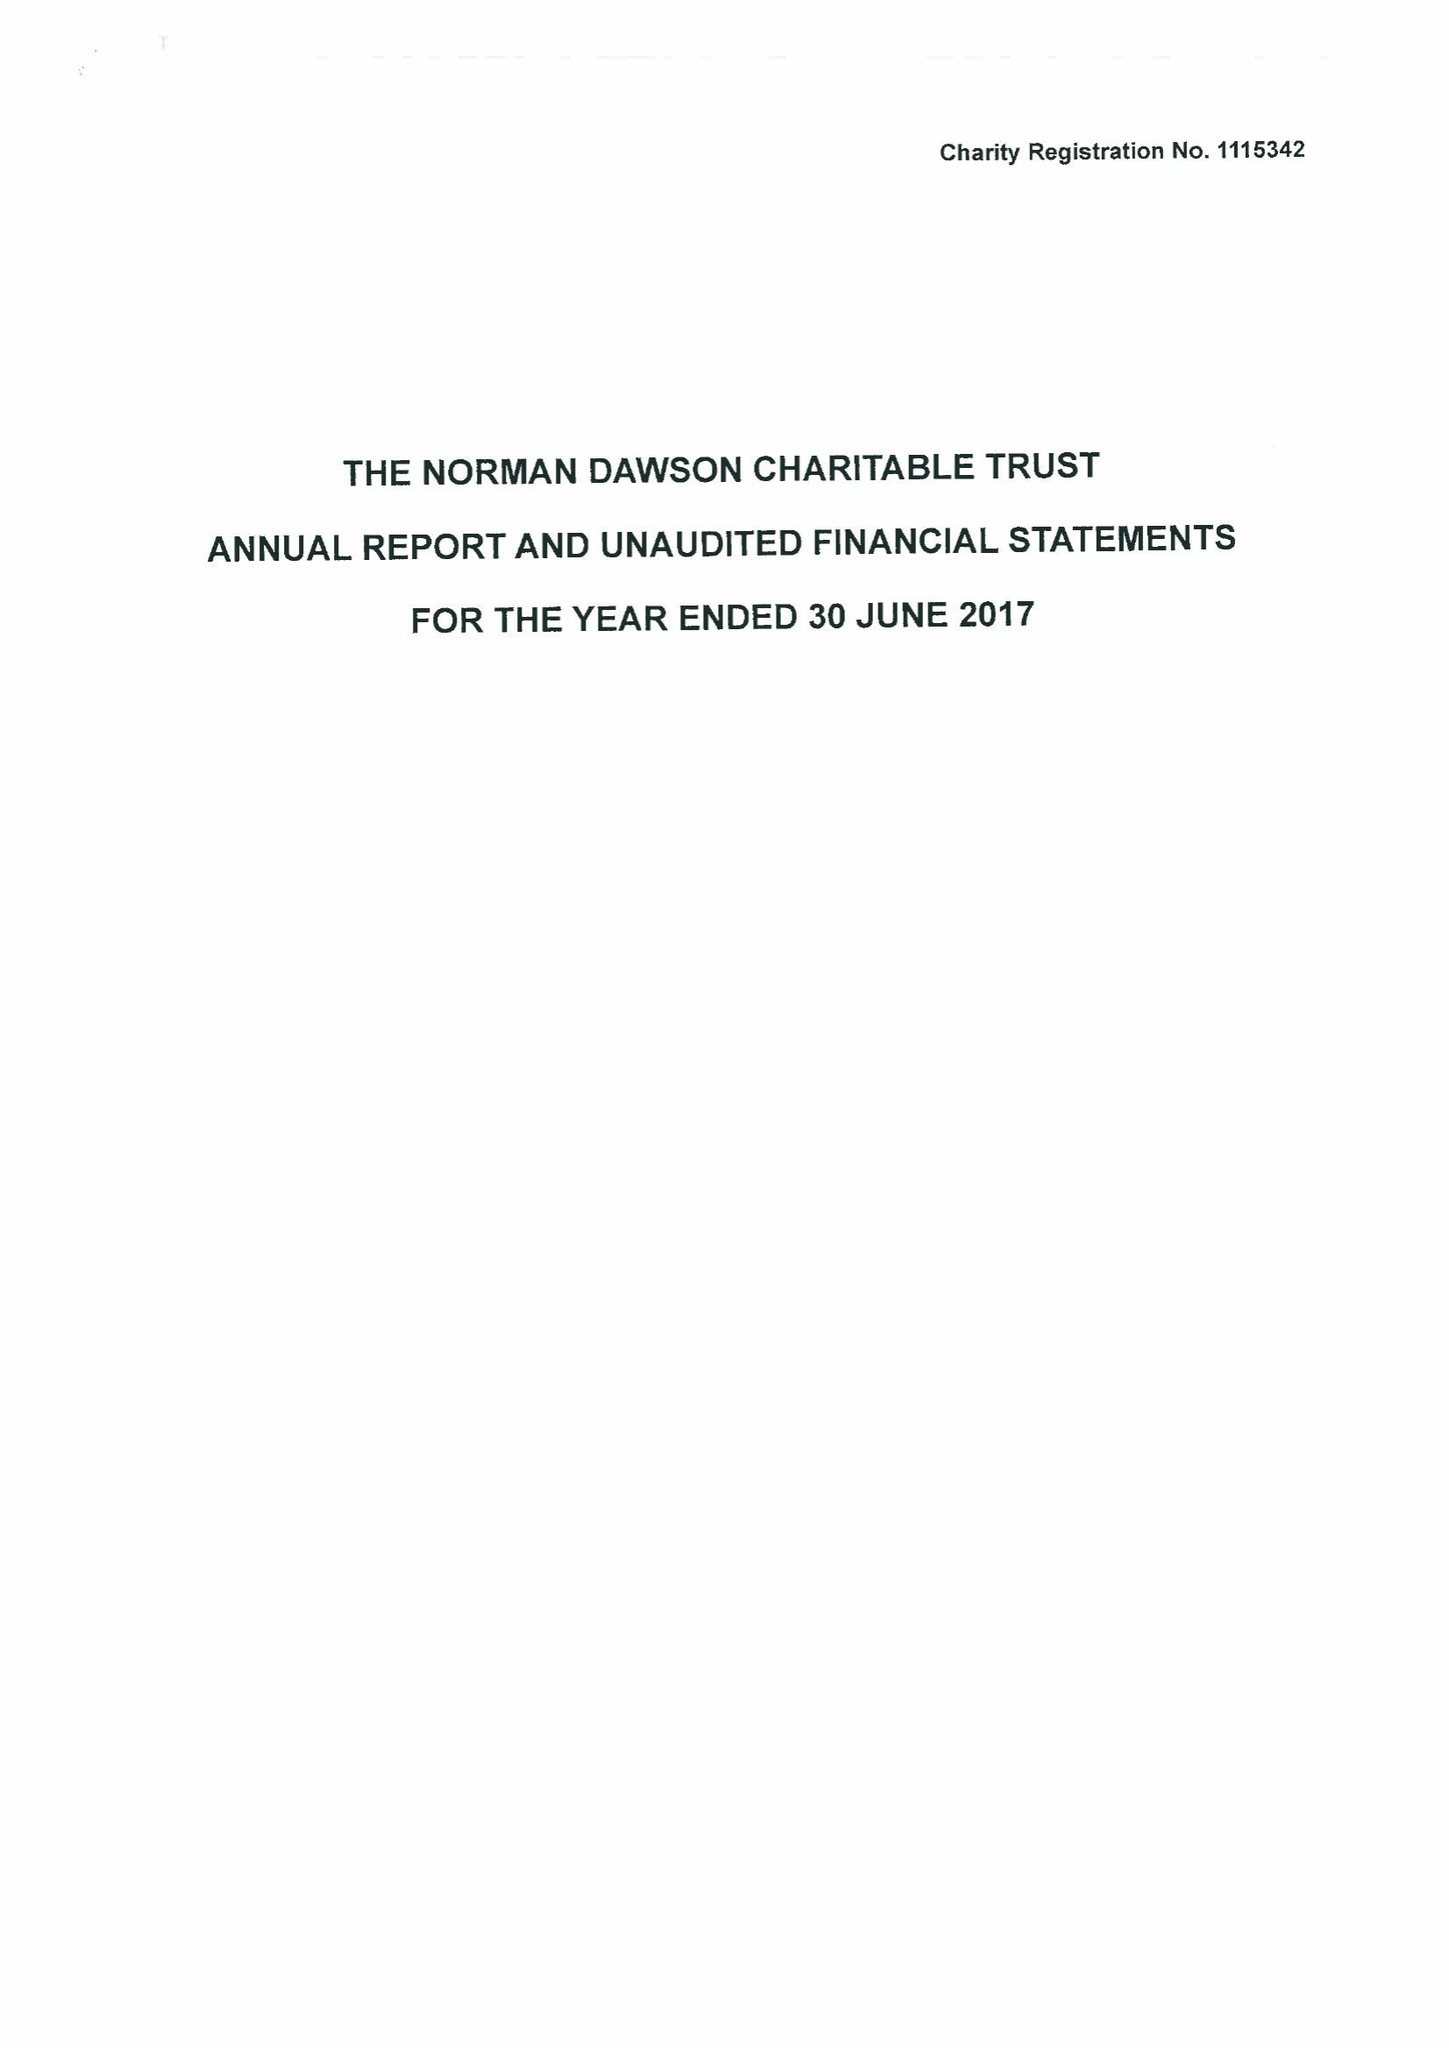What is the value for the charity_name?
Answer the question using a single word or phrase. The Norman Dawson Charitable Trust 